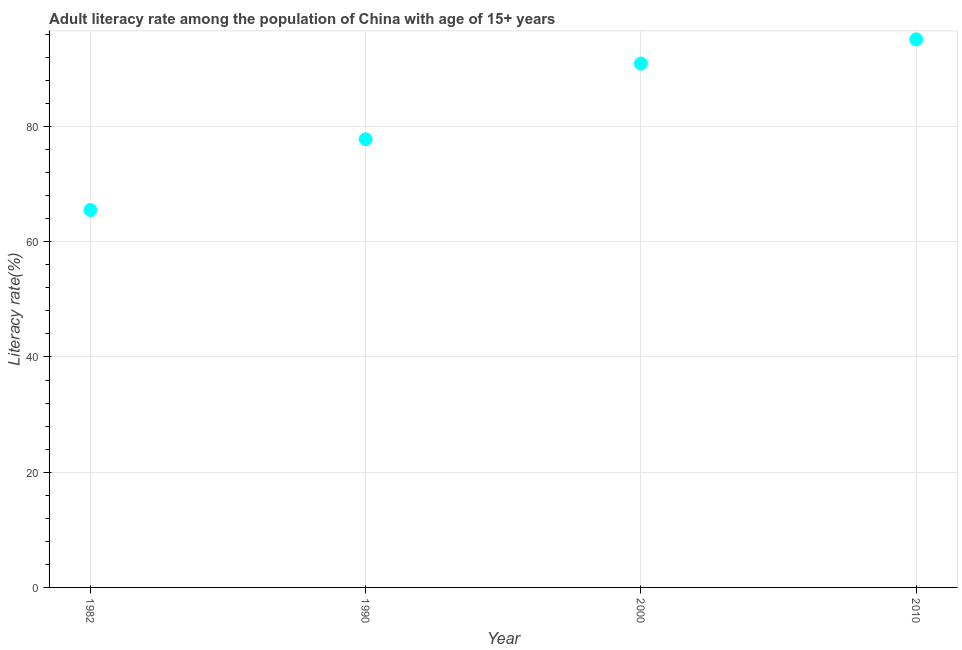What is the adult literacy rate in 2000?
Keep it short and to the point. 90.92. Across all years, what is the maximum adult literacy rate?
Ensure brevity in your answer.  95.12. Across all years, what is the minimum adult literacy rate?
Your answer should be compact. 65.51. In which year was the adult literacy rate maximum?
Your answer should be compact. 2010. In which year was the adult literacy rate minimum?
Provide a succinct answer. 1982. What is the sum of the adult literacy rate?
Offer a very short reply. 329.33. What is the difference between the adult literacy rate in 1982 and 1990?
Provide a succinct answer. -12.28. What is the average adult literacy rate per year?
Your answer should be very brief. 82.33. What is the median adult literacy rate?
Provide a succinct answer. 84.35. In how many years, is the adult literacy rate greater than 32 %?
Ensure brevity in your answer.  4. What is the ratio of the adult literacy rate in 1982 to that in 1990?
Your answer should be compact. 0.84. What is the difference between the highest and the second highest adult literacy rate?
Your response must be concise. 4.2. What is the difference between the highest and the lowest adult literacy rate?
Your answer should be very brief. 29.62. In how many years, is the adult literacy rate greater than the average adult literacy rate taken over all years?
Provide a short and direct response. 2. Does the adult literacy rate monotonically increase over the years?
Offer a very short reply. Yes. How many years are there in the graph?
Offer a very short reply. 4. What is the difference between two consecutive major ticks on the Y-axis?
Your answer should be compact. 20. Does the graph contain any zero values?
Your answer should be compact. No. Does the graph contain grids?
Give a very brief answer. Yes. What is the title of the graph?
Offer a very short reply. Adult literacy rate among the population of China with age of 15+ years. What is the label or title of the Y-axis?
Offer a terse response. Literacy rate(%). What is the Literacy rate(%) in 1982?
Your answer should be compact. 65.51. What is the Literacy rate(%) in 1990?
Offer a very short reply. 77.79. What is the Literacy rate(%) in 2000?
Provide a succinct answer. 90.92. What is the Literacy rate(%) in 2010?
Provide a succinct answer. 95.12. What is the difference between the Literacy rate(%) in 1982 and 1990?
Offer a very short reply. -12.28. What is the difference between the Literacy rate(%) in 1982 and 2000?
Ensure brevity in your answer.  -25.42. What is the difference between the Literacy rate(%) in 1982 and 2010?
Provide a succinct answer. -29.62. What is the difference between the Literacy rate(%) in 1990 and 2000?
Keep it short and to the point. -13.14. What is the difference between the Literacy rate(%) in 1990 and 2010?
Your answer should be very brief. -17.34. What is the difference between the Literacy rate(%) in 2000 and 2010?
Your response must be concise. -4.2. What is the ratio of the Literacy rate(%) in 1982 to that in 1990?
Make the answer very short. 0.84. What is the ratio of the Literacy rate(%) in 1982 to that in 2000?
Keep it short and to the point. 0.72. What is the ratio of the Literacy rate(%) in 1982 to that in 2010?
Make the answer very short. 0.69. What is the ratio of the Literacy rate(%) in 1990 to that in 2000?
Offer a terse response. 0.86. What is the ratio of the Literacy rate(%) in 1990 to that in 2010?
Provide a succinct answer. 0.82. What is the ratio of the Literacy rate(%) in 2000 to that in 2010?
Your answer should be compact. 0.96. 